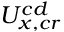<formula> <loc_0><loc_0><loc_500><loc_500>U _ { x , c r } ^ { c d }</formula> 